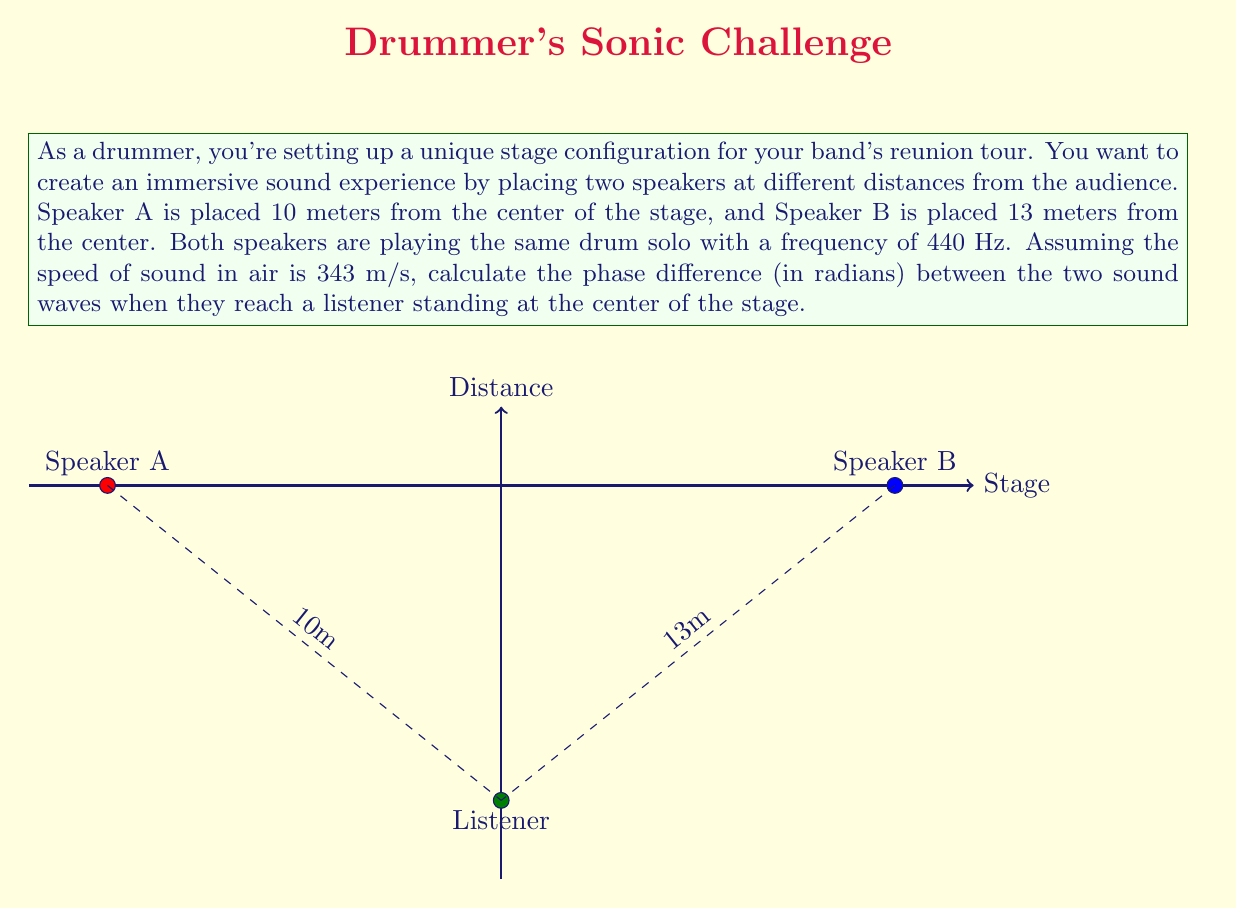Show me your answer to this math problem. Let's approach this step-by-step:

1) First, we need to calculate the wavelength of the sound. The wavelength λ is given by the formula:

   $$λ = \frac{v}{f}$$

   where v is the speed of sound and f is the frequency.

2) Plugging in the values:

   $$λ = \frac{343 \text{ m/s}}{440 \text{ Hz}} = 0.78 \text{ m}$$

3) Now, we need to find the path difference (Δd) between the two speakers:

   $$Δd = 13 \text{ m} - 10 \text{ m} = 3 \text{ m}$$

4) The phase difference (Δφ) in radians is given by:

   $$Δφ = \frac{2π}{\lambda} \cdot Δd$$

5) Substituting our values:

   $$Δφ = \frac{2π}{0.78 \text{ m}} \cdot 3 \text{ m}$$

6) Simplifying:

   $$Δφ = 24.18 \text{ radians}$$

7) We can express this in terms of π:

   $$Δφ = 7.7π \text{ radians}$$
Answer: $7.7π \text{ radians}$ 